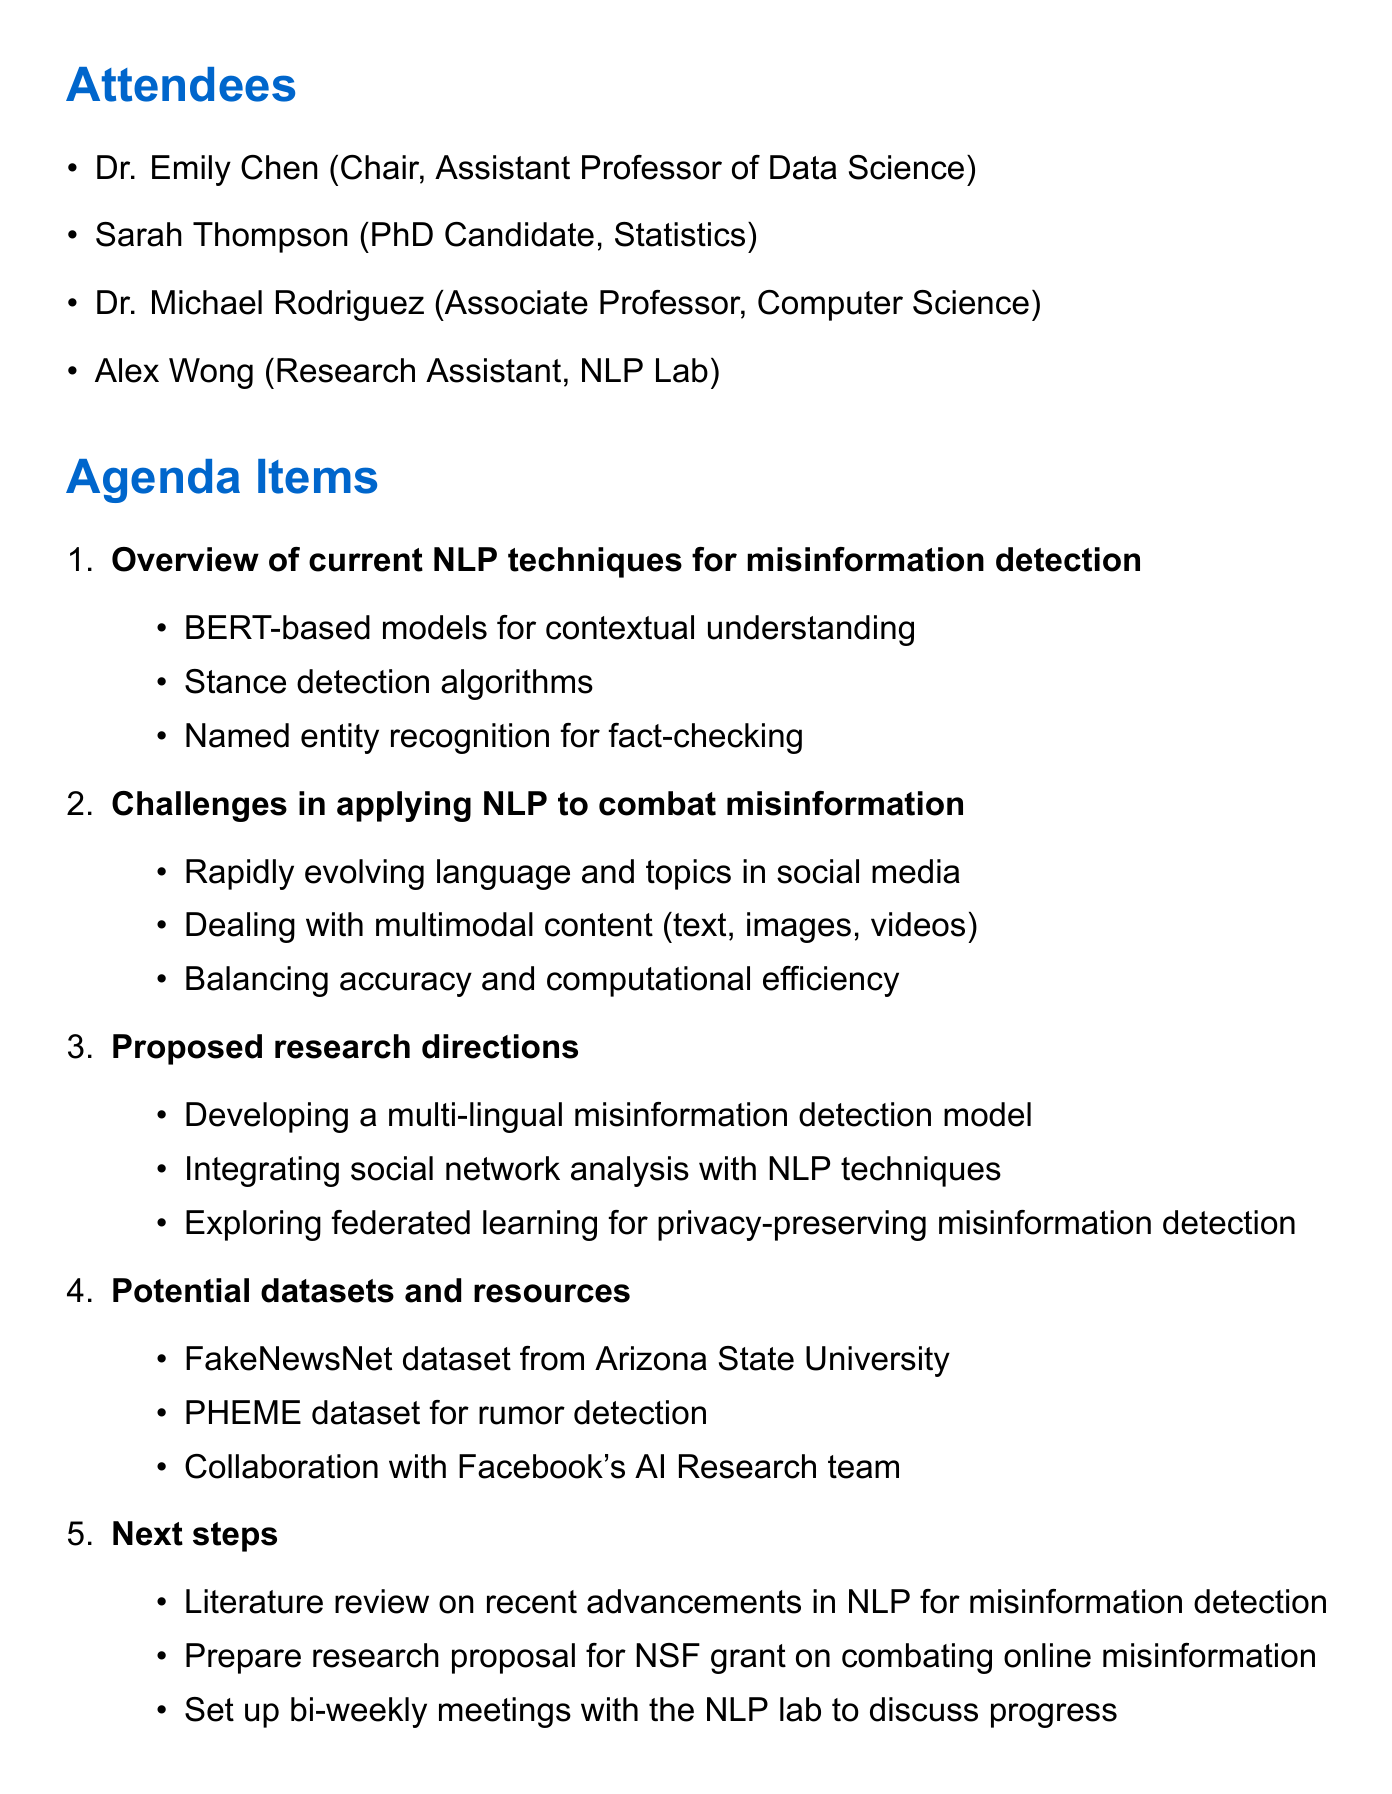What is the date of the meeting? The date of the meeting is explicitly mentioned at the top of the document.
Answer: 2023-05-15 Who is the chair of the meeting? The chair of the meeting is listed in the attendees section, alongside their title.
Answer: Dr. Emily Chen What is one NLP technique discussed for misinformation detection? Several techniques are mentioned under the agenda item for current NLP techniques.
Answer: BERT-based models for contextual understanding What is a challenge mentioned in applying NLP to combat misinformation? Challenges are listed under the agenda item discussing challenges in applying NLP.
Answer: Rapidly evolving language and topics in social media Who is responsible for preparing the NSF grant proposal? Action items include tasks assigned to specific individuals.
Answer: Dr. Emily Chen What is one proposed research direction? Proposed research directions are highlighted under the relevant agenda item.
Answer: Developing a multi-lingual misinformation detection model What is the due date for the literature review? Each action item includes a due date for its completion.
Answer: 2023-05-29 Which dataset is mentioned for rumor detection? The document lists potential datasets under the relevant agenda item.
Answer: PHEME dataset for rumor detection 